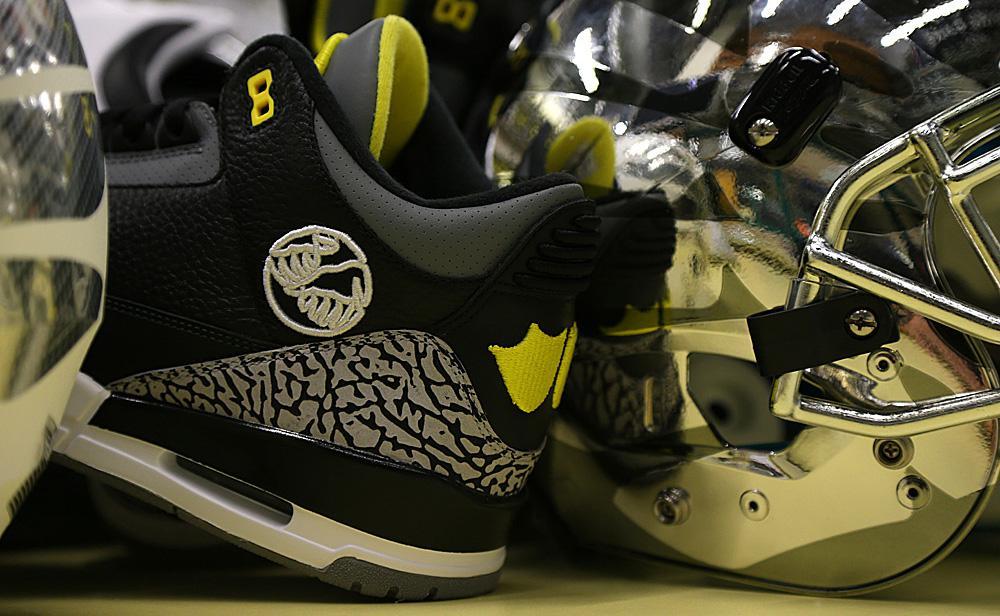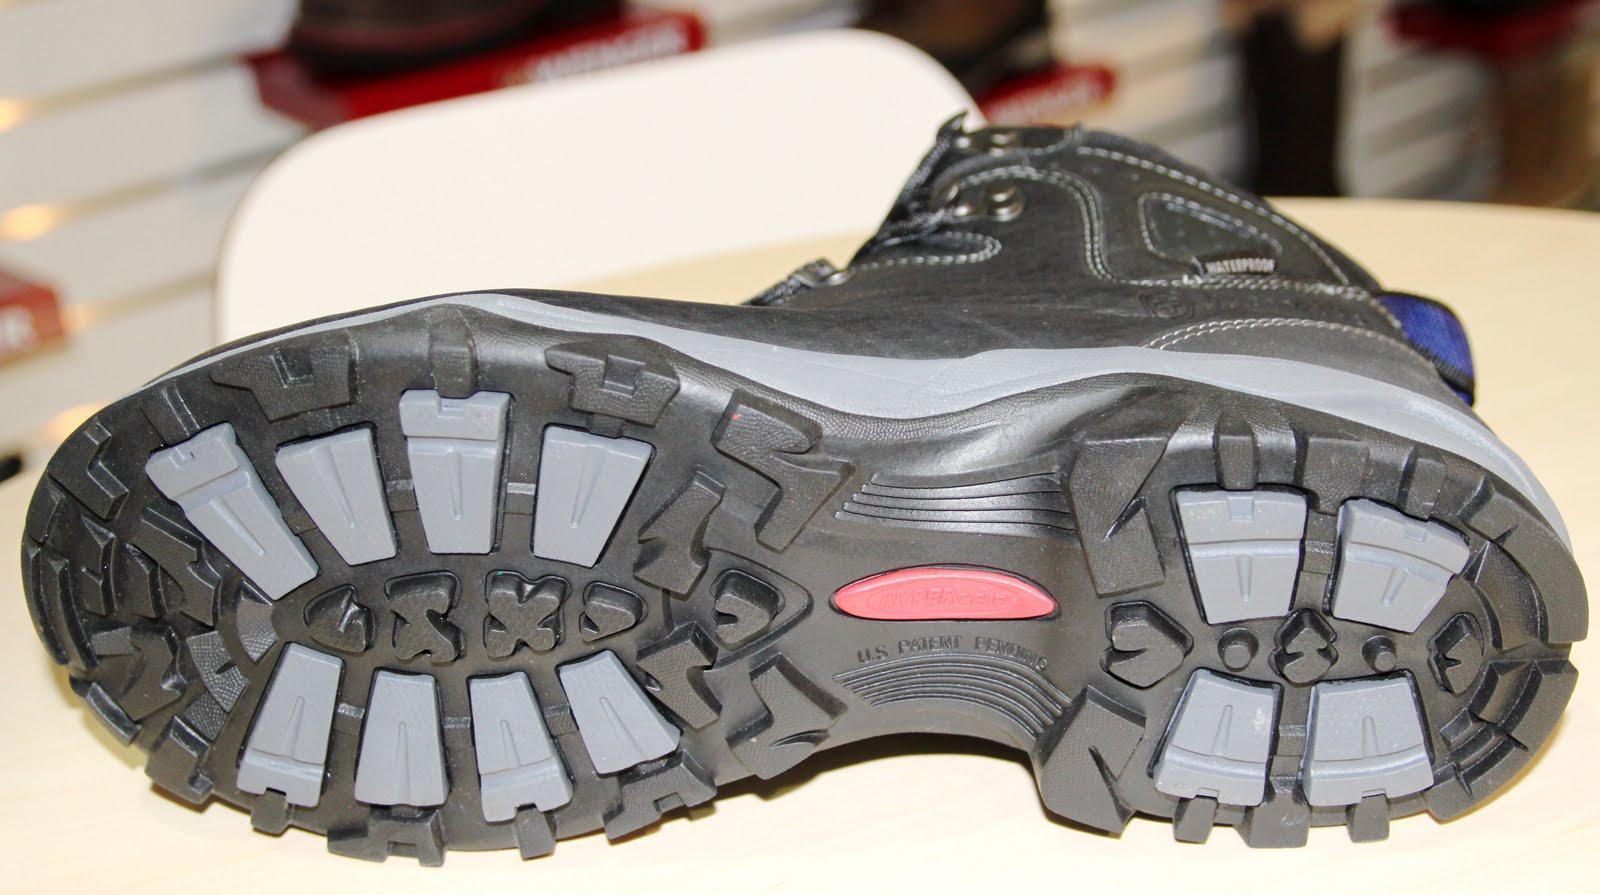The first image is the image on the left, the second image is the image on the right. Considering the images on both sides, is "Some sneakers are brand new and some are not." valid? Answer yes or no. No. The first image is the image on the left, the second image is the image on the right. Examine the images to the left and right. Is the description "There are at least four pairs of shoes." accurate? Answer yes or no. No. 